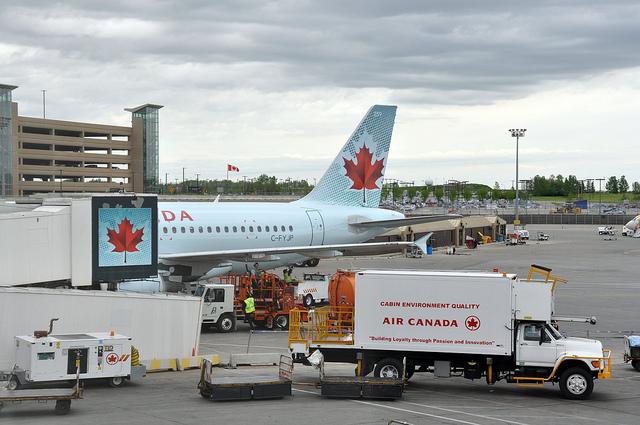How many people are wearing bright yellow vests?
Be succinct. 1. Is it a sunny day?
Quick response, please. No. What country's symbol is on the plane?
Quick response, please. Canada. Whose flag is shown in the image?
Write a very short answer. Canada. 